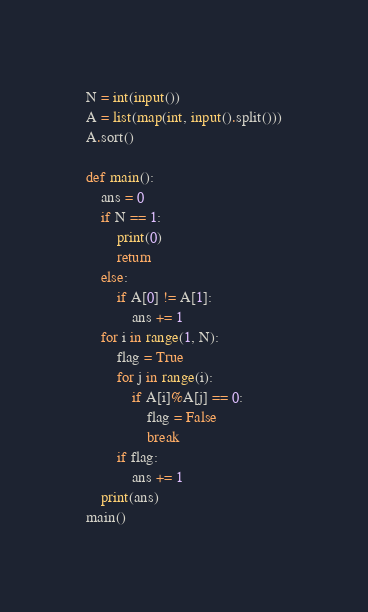<code> <loc_0><loc_0><loc_500><loc_500><_Python_>N = int(input())
A = list(map(int, input().split()))
A.sort()

def main():
    ans = 0
    if N == 1:
        print(0)
        return
    else:
        if A[0] != A[1]:
            ans += 1
    for i in range(1, N):
        flag = True
        for j in range(i):
            if A[i]%A[j] == 0:
                flag = False
                break
        if flag:
            ans += 1
    print(ans)
main()
</code> 